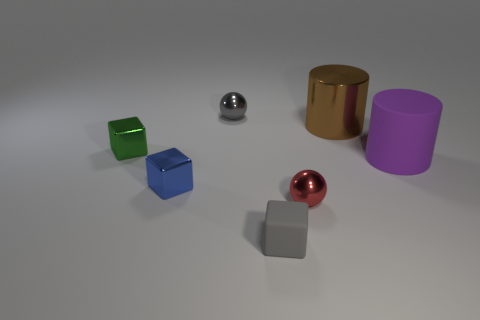What number of tiny gray rubber objects are in front of the green metallic block?
Your answer should be compact. 1. How many spheres are either tiny metallic objects or brown matte objects?
Make the answer very short. 2. There is a thing that is both on the left side of the tiny gray rubber object and on the right side of the tiny blue metallic block; what is its size?
Give a very brief answer. Small. How many other things are there of the same color as the large metal cylinder?
Your answer should be very brief. 0. Are the blue object and the small gray object behind the tiny gray block made of the same material?
Give a very brief answer. Yes. What number of objects are rubber things right of the tiny red metal object or small green shiny blocks?
Give a very brief answer. 2. What shape is the object that is both behind the big purple cylinder and right of the red shiny sphere?
Your response must be concise. Cylinder. Are there any other things that are the same size as the gray block?
Ensure brevity in your answer.  Yes. There is a green cube that is the same material as the tiny blue thing; what size is it?
Offer a terse response. Small. What number of things are shiny balls that are in front of the metallic cylinder or small metal things to the right of the small blue block?
Provide a short and direct response. 2. 